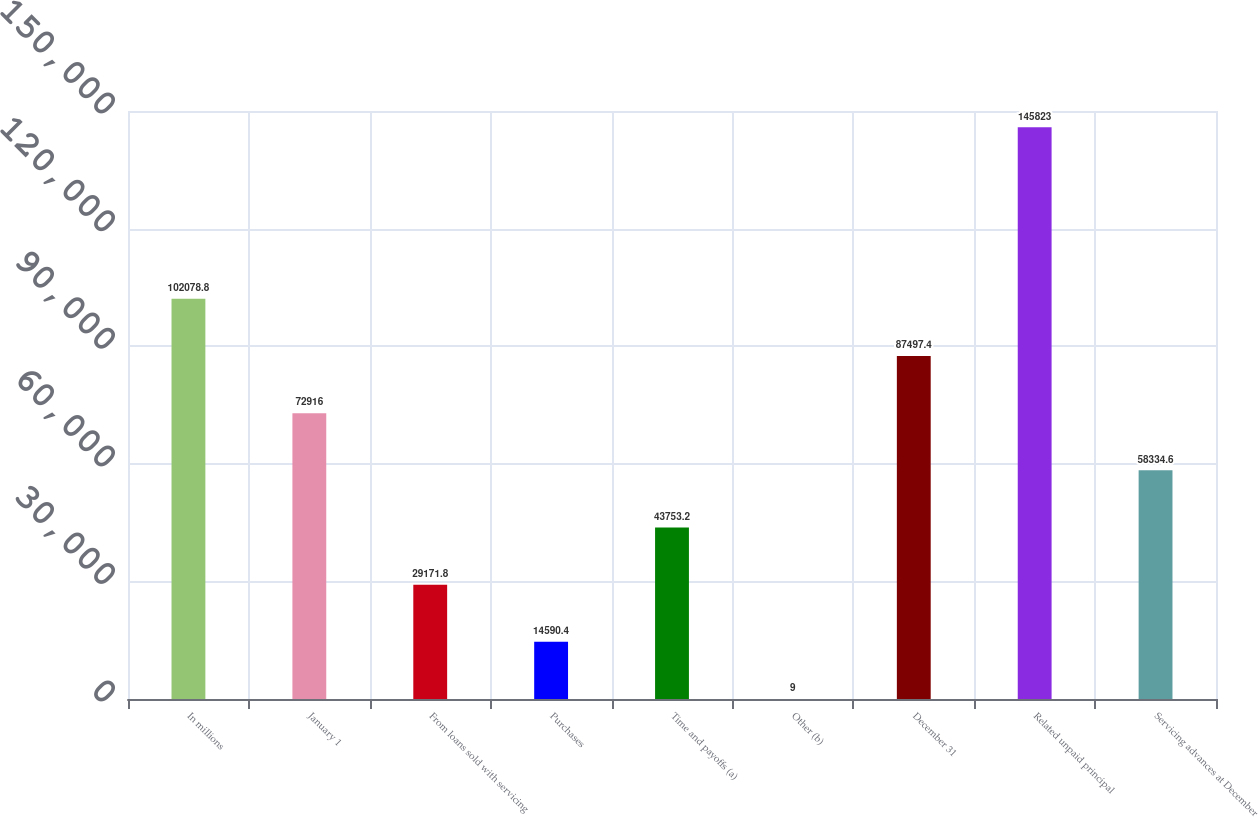<chart> <loc_0><loc_0><loc_500><loc_500><bar_chart><fcel>In millions<fcel>January 1<fcel>From loans sold with servicing<fcel>Purchases<fcel>Time and payoffs (a)<fcel>Other (b)<fcel>December 31<fcel>Related unpaid principal<fcel>Servicing advances at December<nl><fcel>102079<fcel>72916<fcel>29171.8<fcel>14590.4<fcel>43753.2<fcel>9<fcel>87497.4<fcel>145823<fcel>58334.6<nl></chart> 